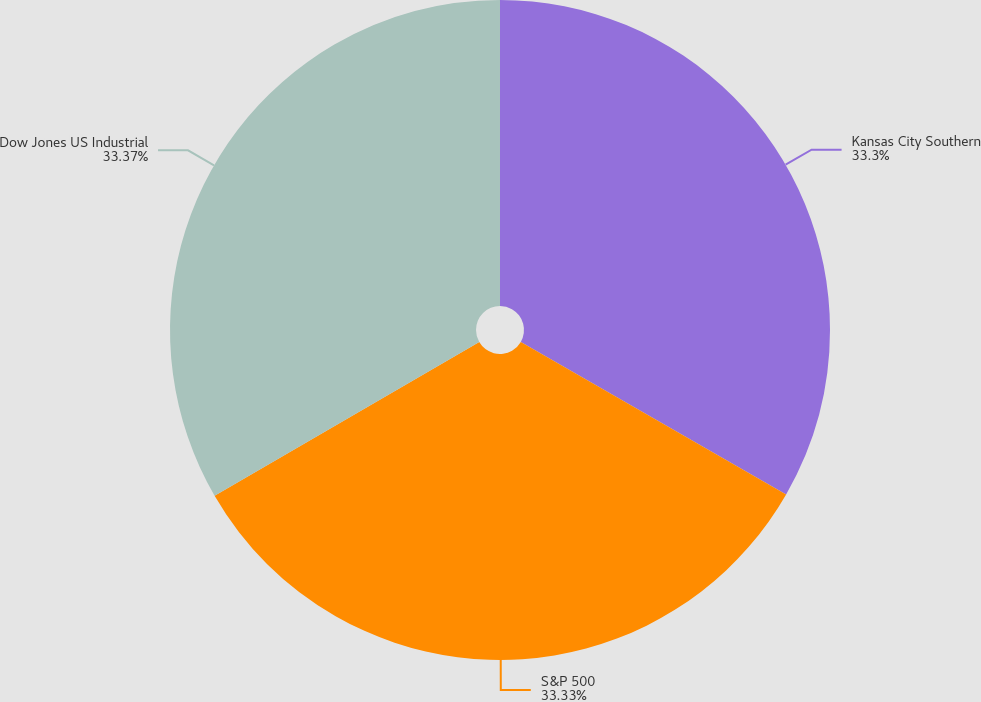<chart> <loc_0><loc_0><loc_500><loc_500><pie_chart><fcel>Kansas City Southern<fcel>S&P 500<fcel>Dow Jones US Industrial<nl><fcel>33.3%<fcel>33.33%<fcel>33.37%<nl></chart> 